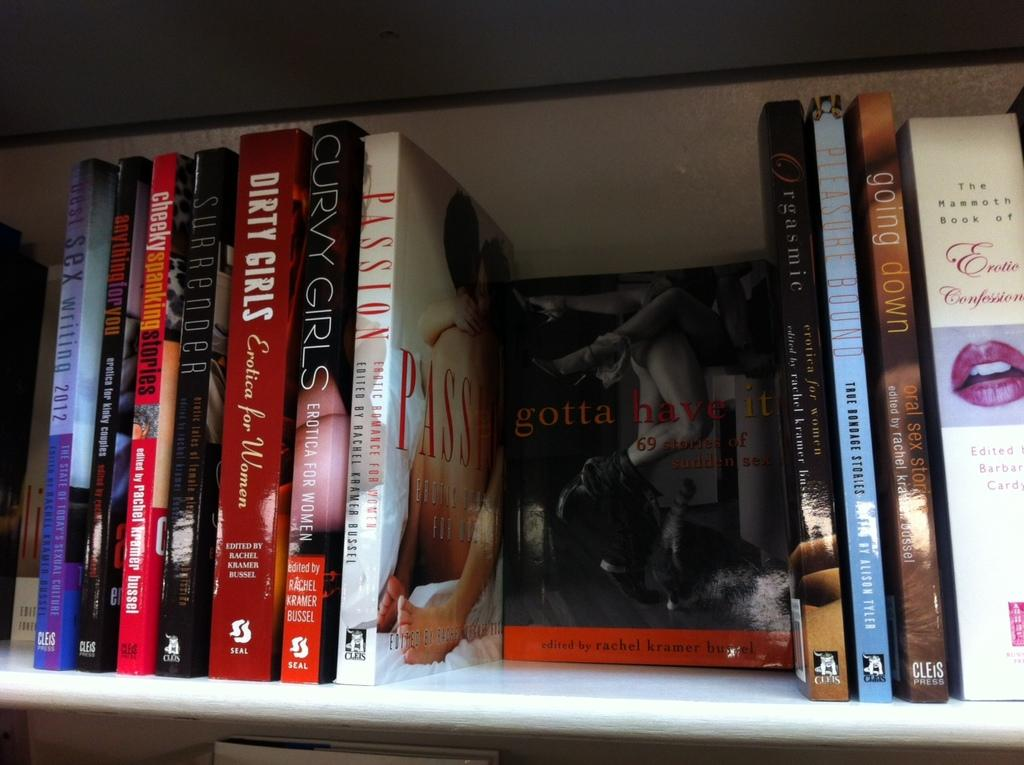Provide a one-sentence caption for the provided image. some books entitled DIRTY GIRLS, CURVY GIRLS, PASSION, gotta have it, going down and more. 